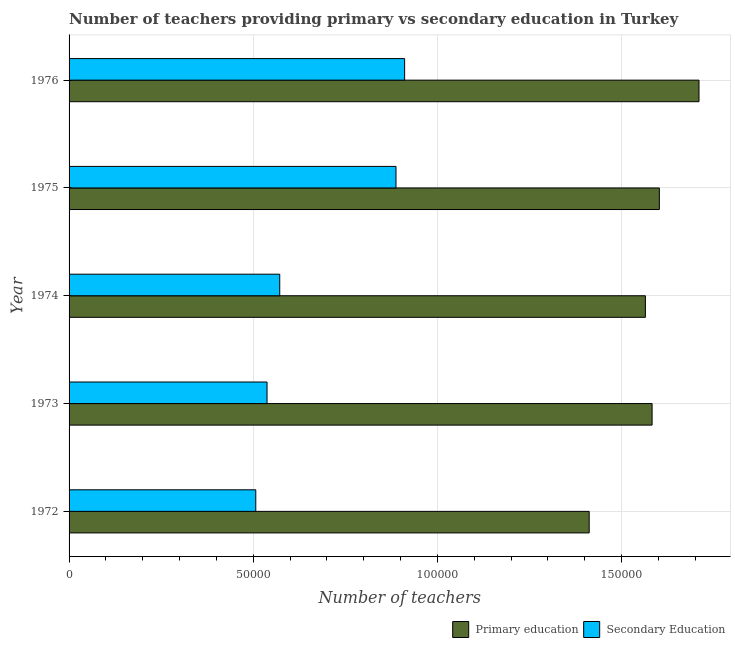How many different coloured bars are there?
Keep it short and to the point. 2. How many groups of bars are there?
Provide a succinct answer. 5. Are the number of bars per tick equal to the number of legend labels?
Give a very brief answer. Yes. Are the number of bars on each tick of the Y-axis equal?
Ensure brevity in your answer.  Yes. How many bars are there on the 1st tick from the top?
Give a very brief answer. 2. How many bars are there on the 4th tick from the bottom?
Provide a succinct answer. 2. In how many cases, is the number of bars for a given year not equal to the number of legend labels?
Your answer should be very brief. 0. What is the number of secondary teachers in 1976?
Keep it short and to the point. 9.11e+04. Across all years, what is the maximum number of primary teachers?
Ensure brevity in your answer.  1.71e+05. Across all years, what is the minimum number of secondary teachers?
Your response must be concise. 5.07e+04. In which year was the number of secondary teachers maximum?
Your answer should be compact. 1976. What is the total number of secondary teachers in the graph?
Provide a succinct answer. 3.42e+05. What is the difference between the number of primary teachers in 1973 and that in 1976?
Your answer should be very brief. -1.27e+04. What is the difference between the number of secondary teachers in 1973 and the number of primary teachers in 1972?
Your response must be concise. -8.75e+04. What is the average number of secondary teachers per year?
Your answer should be compact. 6.83e+04. In the year 1974, what is the difference between the number of secondary teachers and number of primary teachers?
Your response must be concise. -9.93e+04. What is the ratio of the number of secondary teachers in 1975 to that in 1976?
Make the answer very short. 0.97. Is the number of secondary teachers in 1973 less than that in 1976?
Your answer should be very brief. Yes. Is the difference between the number of secondary teachers in 1975 and 1976 greater than the difference between the number of primary teachers in 1975 and 1976?
Offer a terse response. Yes. What is the difference between the highest and the second highest number of secondary teachers?
Your answer should be compact. 2343. What is the difference between the highest and the lowest number of primary teachers?
Your answer should be compact. 2.98e+04. What does the 1st bar from the top in 1972 represents?
Offer a terse response. Secondary Education. How many bars are there?
Provide a succinct answer. 10. How many years are there in the graph?
Provide a succinct answer. 5. What is the difference between two consecutive major ticks on the X-axis?
Make the answer very short. 5.00e+04. Does the graph contain any zero values?
Provide a succinct answer. No. Where does the legend appear in the graph?
Your answer should be very brief. Bottom right. How many legend labels are there?
Your answer should be compact. 2. What is the title of the graph?
Your answer should be very brief. Number of teachers providing primary vs secondary education in Turkey. Does "Education" appear as one of the legend labels in the graph?
Keep it short and to the point. No. What is the label or title of the X-axis?
Your response must be concise. Number of teachers. What is the Number of teachers in Primary education in 1972?
Make the answer very short. 1.41e+05. What is the Number of teachers in Secondary Education in 1972?
Provide a short and direct response. 5.07e+04. What is the Number of teachers of Primary education in 1973?
Your answer should be very brief. 1.58e+05. What is the Number of teachers of Secondary Education in 1973?
Offer a terse response. 5.38e+04. What is the Number of teachers in Primary education in 1974?
Provide a short and direct response. 1.56e+05. What is the Number of teachers of Secondary Education in 1974?
Give a very brief answer. 5.72e+04. What is the Number of teachers of Primary education in 1975?
Offer a very short reply. 1.60e+05. What is the Number of teachers in Secondary Education in 1975?
Offer a terse response. 8.88e+04. What is the Number of teachers of Primary education in 1976?
Your response must be concise. 1.71e+05. What is the Number of teachers of Secondary Education in 1976?
Give a very brief answer. 9.11e+04. Across all years, what is the maximum Number of teachers in Primary education?
Provide a succinct answer. 1.71e+05. Across all years, what is the maximum Number of teachers of Secondary Education?
Your answer should be very brief. 9.11e+04. Across all years, what is the minimum Number of teachers of Primary education?
Your response must be concise. 1.41e+05. Across all years, what is the minimum Number of teachers of Secondary Education?
Provide a succinct answer. 5.07e+04. What is the total Number of teachers in Primary education in the graph?
Your response must be concise. 7.87e+05. What is the total Number of teachers in Secondary Education in the graph?
Your response must be concise. 3.42e+05. What is the difference between the Number of teachers of Primary education in 1972 and that in 1973?
Your answer should be compact. -1.71e+04. What is the difference between the Number of teachers in Secondary Education in 1972 and that in 1973?
Provide a short and direct response. -3058. What is the difference between the Number of teachers of Primary education in 1972 and that in 1974?
Ensure brevity in your answer.  -1.53e+04. What is the difference between the Number of teachers in Secondary Education in 1972 and that in 1974?
Offer a very short reply. -6507. What is the difference between the Number of teachers of Primary education in 1972 and that in 1975?
Your response must be concise. -1.91e+04. What is the difference between the Number of teachers in Secondary Education in 1972 and that in 1975?
Your answer should be very brief. -3.81e+04. What is the difference between the Number of teachers in Primary education in 1972 and that in 1976?
Make the answer very short. -2.98e+04. What is the difference between the Number of teachers in Secondary Education in 1972 and that in 1976?
Your response must be concise. -4.04e+04. What is the difference between the Number of teachers in Primary education in 1973 and that in 1974?
Keep it short and to the point. 1823. What is the difference between the Number of teachers in Secondary Education in 1973 and that in 1974?
Your response must be concise. -3449. What is the difference between the Number of teachers in Primary education in 1973 and that in 1975?
Make the answer very short. -1972. What is the difference between the Number of teachers in Secondary Education in 1973 and that in 1975?
Keep it short and to the point. -3.50e+04. What is the difference between the Number of teachers of Primary education in 1973 and that in 1976?
Keep it short and to the point. -1.27e+04. What is the difference between the Number of teachers in Secondary Education in 1973 and that in 1976?
Offer a terse response. -3.74e+04. What is the difference between the Number of teachers in Primary education in 1974 and that in 1975?
Offer a very short reply. -3795. What is the difference between the Number of teachers of Secondary Education in 1974 and that in 1975?
Give a very brief answer. -3.16e+04. What is the difference between the Number of teachers in Primary education in 1974 and that in 1976?
Provide a short and direct response. -1.46e+04. What is the difference between the Number of teachers in Secondary Education in 1974 and that in 1976?
Provide a succinct answer. -3.39e+04. What is the difference between the Number of teachers of Primary education in 1975 and that in 1976?
Offer a very short reply. -1.08e+04. What is the difference between the Number of teachers of Secondary Education in 1975 and that in 1976?
Give a very brief answer. -2343. What is the difference between the Number of teachers in Primary education in 1972 and the Number of teachers in Secondary Education in 1973?
Your answer should be very brief. 8.75e+04. What is the difference between the Number of teachers in Primary education in 1972 and the Number of teachers in Secondary Education in 1974?
Ensure brevity in your answer.  8.40e+04. What is the difference between the Number of teachers of Primary education in 1972 and the Number of teachers of Secondary Education in 1975?
Your response must be concise. 5.25e+04. What is the difference between the Number of teachers in Primary education in 1972 and the Number of teachers in Secondary Education in 1976?
Ensure brevity in your answer.  5.01e+04. What is the difference between the Number of teachers of Primary education in 1973 and the Number of teachers of Secondary Education in 1974?
Offer a terse response. 1.01e+05. What is the difference between the Number of teachers of Primary education in 1973 and the Number of teachers of Secondary Education in 1975?
Your answer should be compact. 6.95e+04. What is the difference between the Number of teachers in Primary education in 1973 and the Number of teachers in Secondary Education in 1976?
Offer a terse response. 6.72e+04. What is the difference between the Number of teachers in Primary education in 1974 and the Number of teachers in Secondary Education in 1975?
Your answer should be very brief. 6.77e+04. What is the difference between the Number of teachers in Primary education in 1974 and the Number of teachers in Secondary Education in 1976?
Your response must be concise. 6.54e+04. What is the difference between the Number of teachers of Primary education in 1975 and the Number of teachers of Secondary Education in 1976?
Make the answer very short. 6.92e+04. What is the average Number of teachers in Primary education per year?
Your response must be concise. 1.57e+05. What is the average Number of teachers in Secondary Education per year?
Your answer should be very brief. 6.83e+04. In the year 1972, what is the difference between the Number of teachers in Primary education and Number of teachers in Secondary Education?
Provide a succinct answer. 9.05e+04. In the year 1973, what is the difference between the Number of teachers of Primary education and Number of teachers of Secondary Education?
Offer a very short reply. 1.05e+05. In the year 1974, what is the difference between the Number of teachers in Primary education and Number of teachers in Secondary Education?
Your answer should be compact. 9.93e+04. In the year 1975, what is the difference between the Number of teachers in Primary education and Number of teachers in Secondary Education?
Offer a terse response. 7.15e+04. In the year 1976, what is the difference between the Number of teachers of Primary education and Number of teachers of Secondary Education?
Provide a succinct answer. 7.99e+04. What is the ratio of the Number of teachers in Primary education in 1972 to that in 1973?
Keep it short and to the point. 0.89. What is the ratio of the Number of teachers of Secondary Education in 1972 to that in 1973?
Provide a succinct answer. 0.94. What is the ratio of the Number of teachers of Primary education in 1972 to that in 1974?
Ensure brevity in your answer.  0.9. What is the ratio of the Number of teachers in Secondary Education in 1972 to that in 1974?
Keep it short and to the point. 0.89. What is the ratio of the Number of teachers of Primary education in 1972 to that in 1975?
Give a very brief answer. 0.88. What is the ratio of the Number of teachers of Secondary Education in 1972 to that in 1975?
Provide a succinct answer. 0.57. What is the ratio of the Number of teachers in Primary education in 1972 to that in 1976?
Offer a terse response. 0.83. What is the ratio of the Number of teachers in Secondary Education in 1972 to that in 1976?
Make the answer very short. 0.56. What is the ratio of the Number of teachers in Primary education in 1973 to that in 1974?
Keep it short and to the point. 1.01. What is the ratio of the Number of teachers of Secondary Education in 1973 to that in 1974?
Your answer should be compact. 0.94. What is the ratio of the Number of teachers in Secondary Education in 1973 to that in 1975?
Make the answer very short. 0.61. What is the ratio of the Number of teachers of Primary education in 1973 to that in 1976?
Keep it short and to the point. 0.93. What is the ratio of the Number of teachers in Secondary Education in 1973 to that in 1976?
Keep it short and to the point. 0.59. What is the ratio of the Number of teachers in Primary education in 1974 to that in 1975?
Offer a very short reply. 0.98. What is the ratio of the Number of teachers in Secondary Education in 1974 to that in 1975?
Your answer should be compact. 0.64. What is the ratio of the Number of teachers in Primary education in 1974 to that in 1976?
Offer a terse response. 0.91. What is the ratio of the Number of teachers of Secondary Education in 1974 to that in 1976?
Your response must be concise. 0.63. What is the ratio of the Number of teachers of Primary education in 1975 to that in 1976?
Your response must be concise. 0.94. What is the ratio of the Number of teachers in Secondary Education in 1975 to that in 1976?
Make the answer very short. 0.97. What is the difference between the highest and the second highest Number of teachers in Primary education?
Offer a very short reply. 1.08e+04. What is the difference between the highest and the second highest Number of teachers of Secondary Education?
Ensure brevity in your answer.  2343. What is the difference between the highest and the lowest Number of teachers in Primary education?
Offer a very short reply. 2.98e+04. What is the difference between the highest and the lowest Number of teachers in Secondary Education?
Ensure brevity in your answer.  4.04e+04. 